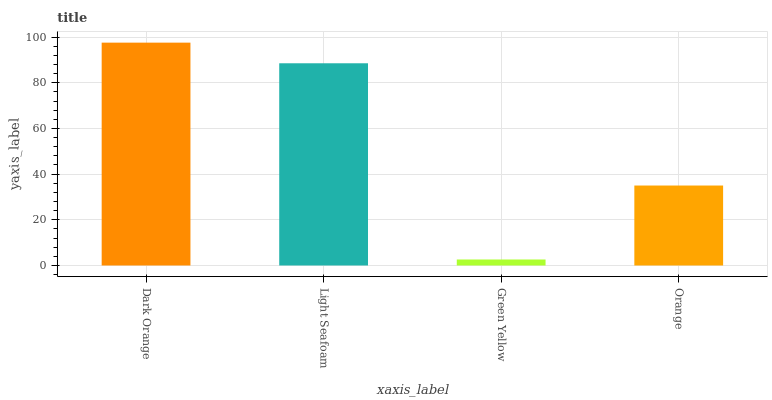Is Green Yellow the minimum?
Answer yes or no. Yes. Is Dark Orange the maximum?
Answer yes or no. Yes. Is Light Seafoam the minimum?
Answer yes or no. No. Is Light Seafoam the maximum?
Answer yes or no. No. Is Dark Orange greater than Light Seafoam?
Answer yes or no. Yes. Is Light Seafoam less than Dark Orange?
Answer yes or no. Yes. Is Light Seafoam greater than Dark Orange?
Answer yes or no. No. Is Dark Orange less than Light Seafoam?
Answer yes or no. No. Is Light Seafoam the high median?
Answer yes or no. Yes. Is Orange the low median?
Answer yes or no. Yes. Is Green Yellow the high median?
Answer yes or no. No. Is Light Seafoam the low median?
Answer yes or no. No. 